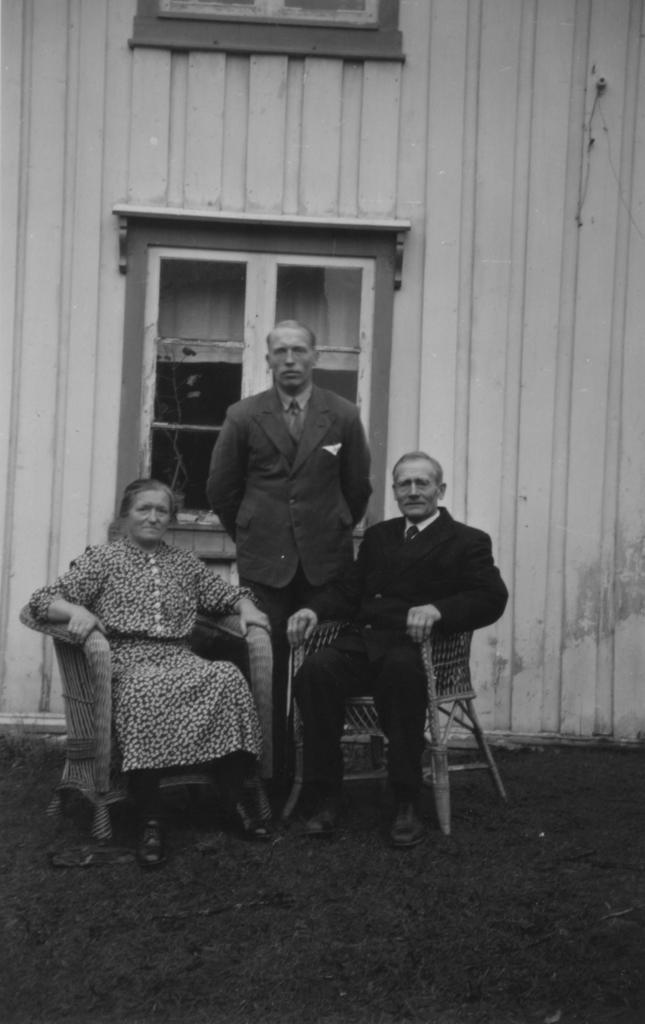How many people are in the image? There are three persons in the image. What are the positions of the two seated persons? Two of the persons are sitting in chairs. What is the position of the third person? One person is standing behind the seated persons. What can be seen in the background of the image? There is a wall and a window in the background of the image. What type of digestion activity is happening in the image? There is no digestion activity visible in the image. Is it raining in the image? There is no indication of rain in the image. 